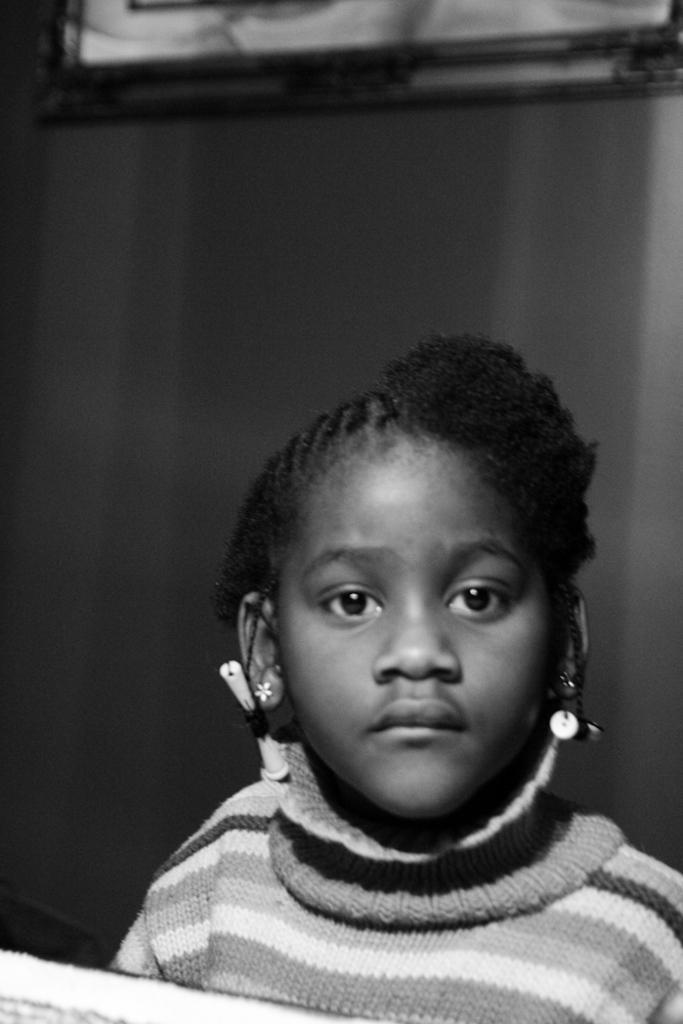In one or two sentences, can you explain what this image depicts? In this picture we can see a girl, some objects and in the background we can see a frame on the wall. 